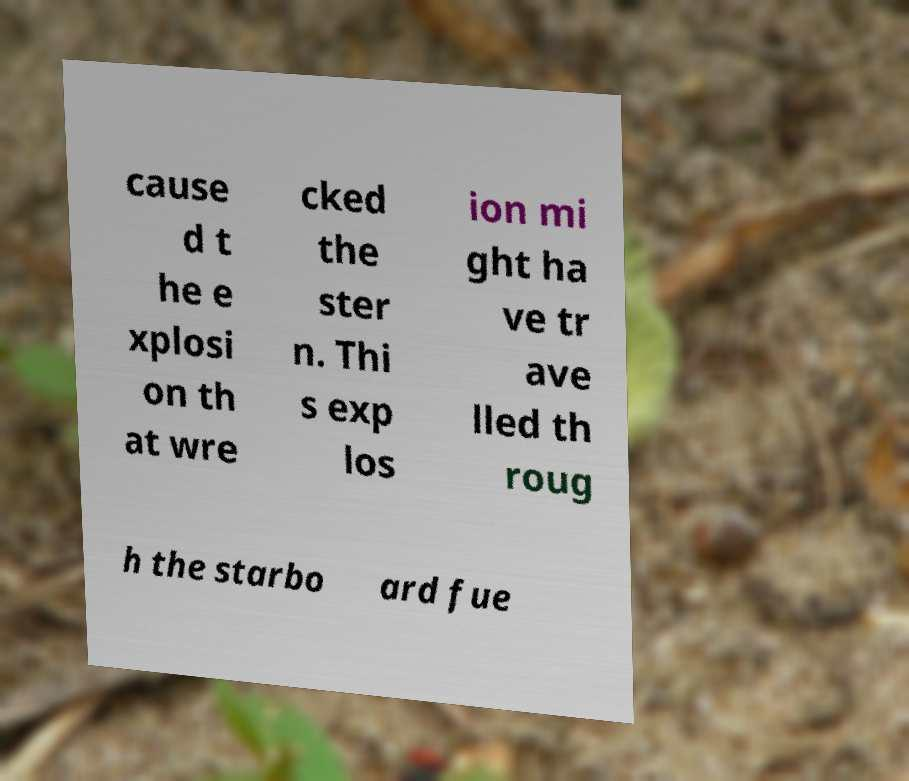Could you extract and type out the text from this image? cause d t he e xplosi on th at wre cked the ster n. Thi s exp los ion mi ght ha ve tr ave lled th roug h the starbo ard fue 